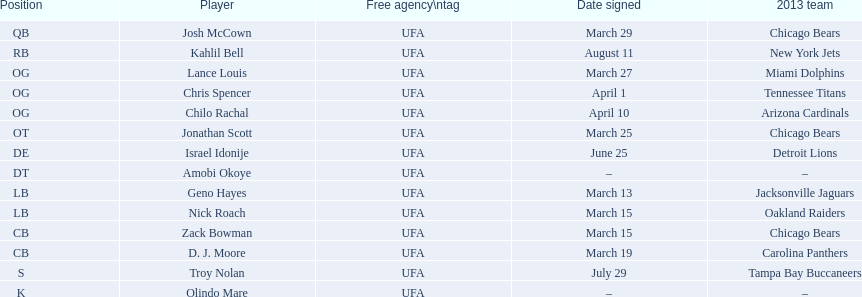How many players were recruited in march? 7. 